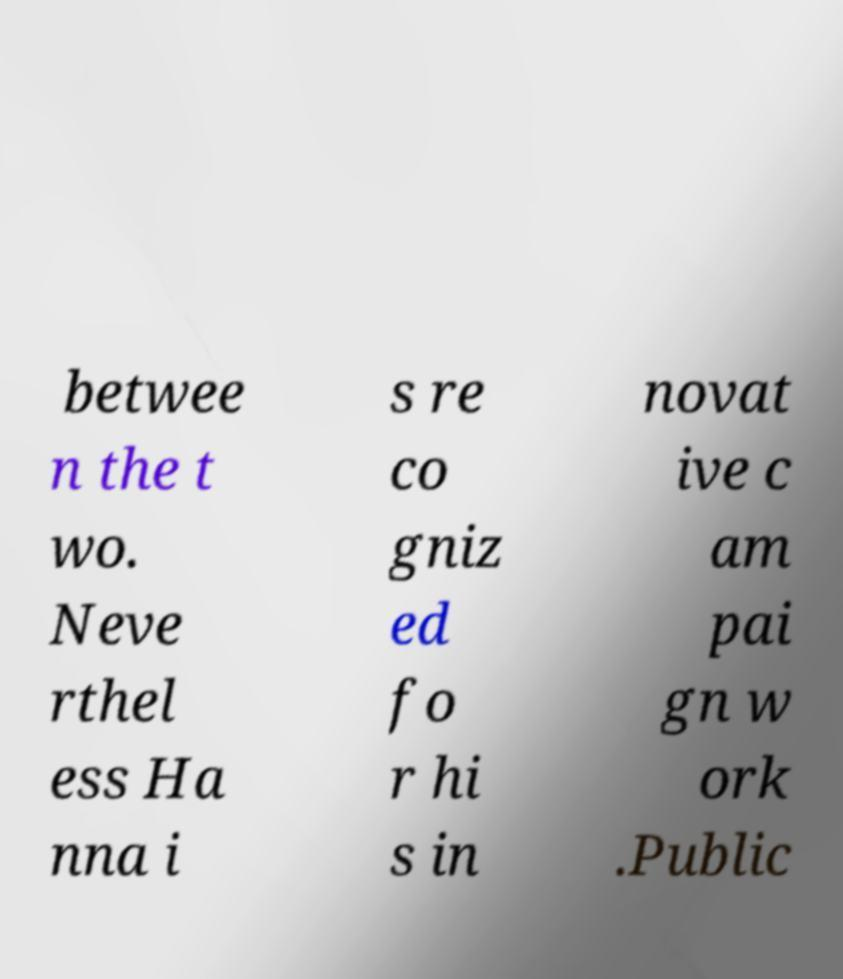For documentation purposes, I need the text within this image transcribed. Could you provide that? betwee n the t wo. Neve rthel ess Ha nna i s re co gniz ed fo r hi s in novat ive c am pai gn w ork .Public 